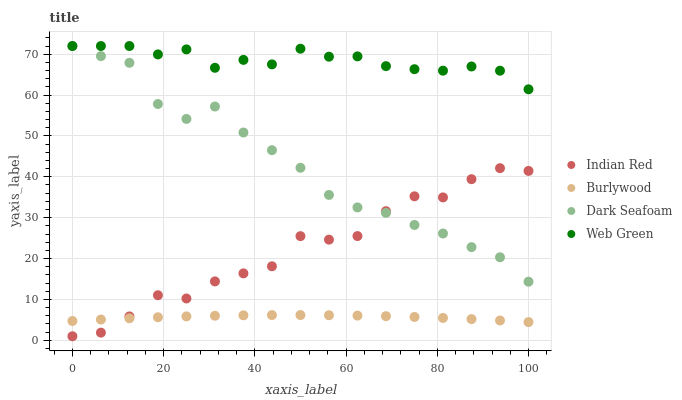Does Burlywood have the minimum area under the curve?
Answer yes or no. Yes. Does Web Green have the maximum area under the curve?
Answer yes or no. Yes. Does Dark Seafoam have the minimum area under the curve?
Answer yes or no. No. Does Dark Seafoam have the maximum area under the curve?
Answer yes or no. No. Is Burlywood the smoothest?
Answer yes or no. Yes. Is Indian Red the roughest?
Answer yes or no. Yes. Is Dark Seafoam the smoothest?
Answer yes or no. No. Is Dark Seafoam the roughest?
Answer yes or no. No. Does Indian Red have the lowest value?
Answer yes or no. Yes. Does Dark Seafoam have the lowest value?
Answer yes or no. No. Does Web Green have the highest value?
Answer yes or no. Yes. Does Indian Red have the highest value?
Answer yes or no. No. Is Burlywood less than Dark Seafoam?
Answer yes or no. Yes. Is Web Green greater than Burlywood?
Answer yes or no. Yes. Does Dark Seafoam intersect Indian Red?
Answer yes or no. Yes. Is Dark Seafoam less than Indian Red?
Answer yes or no. No. Is Dark Seafoam greater than Indian Red?
Answer yes or no. No. Does Burlywood intersect Dark Seafoam?
Answer yes or no. No. 